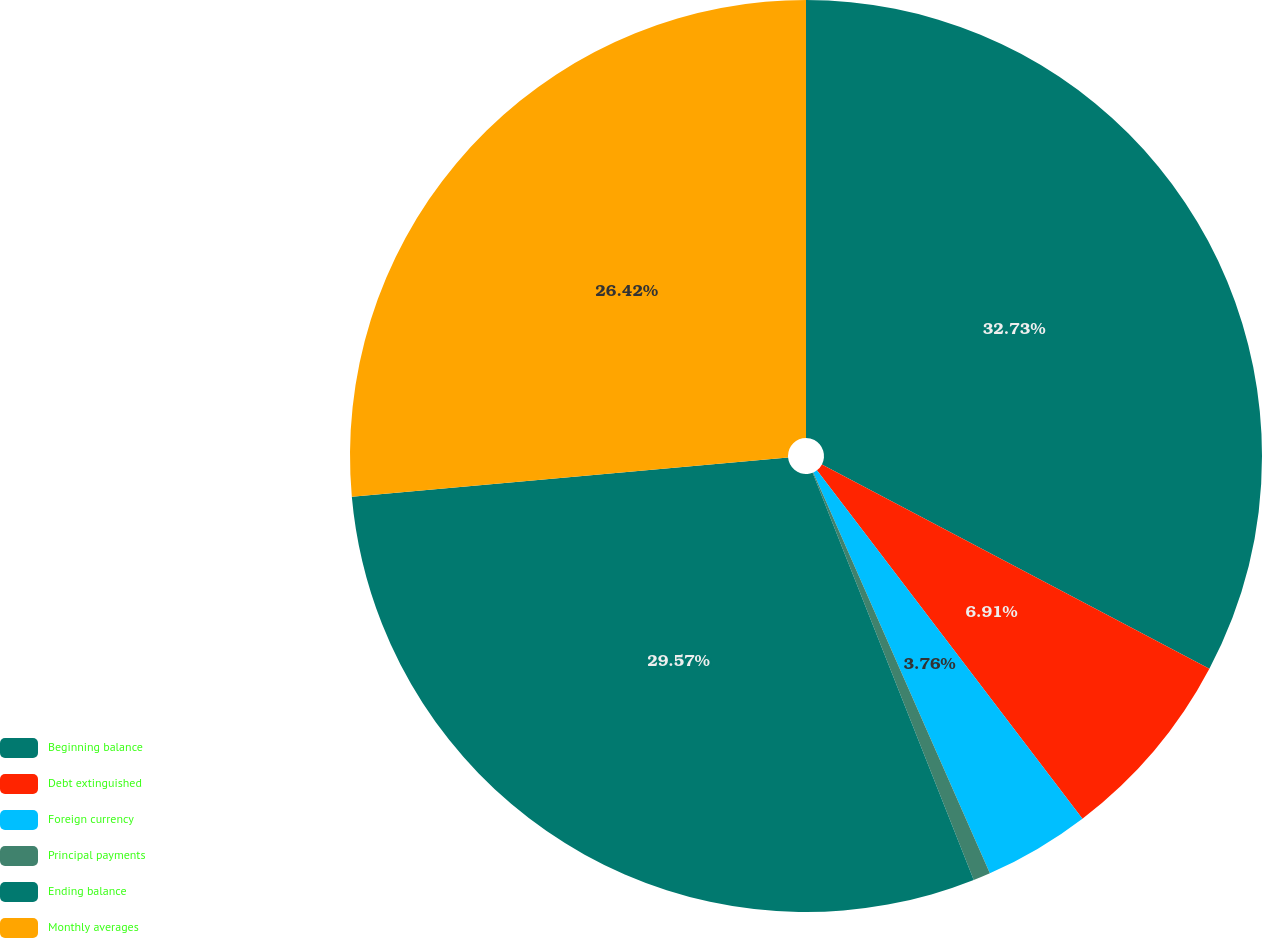Convert chart. <chart><loc_0><loc_0><loc_500><loc_500><pie_chart><fcel>Beginning balance<fcel>Debt extinguished<fcel>Foreign currency<fcel>Principal payments<fcel>Ending balance<fcel>Monthly averages<nl><fcel>32.72%<fcel>6.91%<fcel>3.76%<fcel>0.61%<fcel>29.57%<fcel>26.42%<nl></chart> 